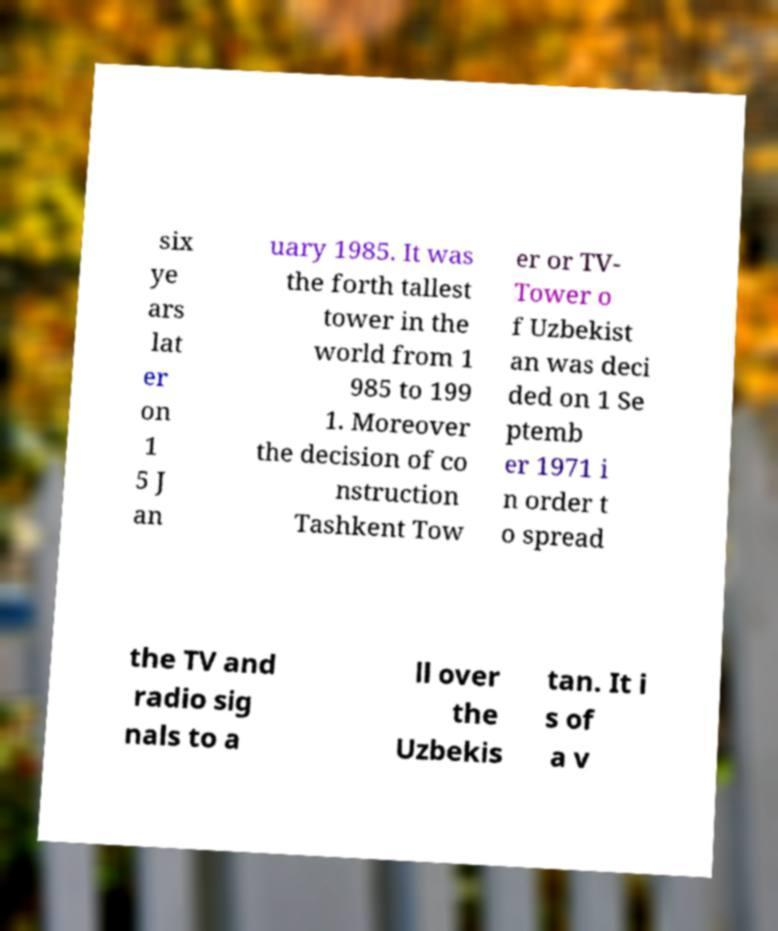Could you extract and type out the text from this image? six ye ars lat er on 1 5 J an uary 1985. It was the forth tallest tower in the world from 1 985 to 199 1. Moreover the decision of co nstruction Tashkent Tow er or TV- Tower o f Uzbekist an was deci ded on 1 Se ptemb er 1971 i n order t o spread the TV and radio sig nals to a ll over the Uzbekis tan. It i s of a v 